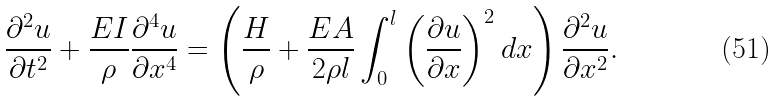Convert formula to latex. <formula><loc_0><loc_0><loc_500><loc_500>\frac { \partial ^ { 2 } u } { \partial t ^ { 2 } } + \frac { E I } { \rho } \frac { \partial ^ { 4 } u } { \partial x ^ { 4 } } = \left ( \frac { H } { \rho } + \frac { E A } { 2 \rho l } \int _ { 0 } ^ { l } \left ( \frac { \partial u } { \partial x } \right ) ^ { 2 } d x \right ) \frac { \partial ^ { 2 } u } { \partial x ^ { 2 } } .</formula> 